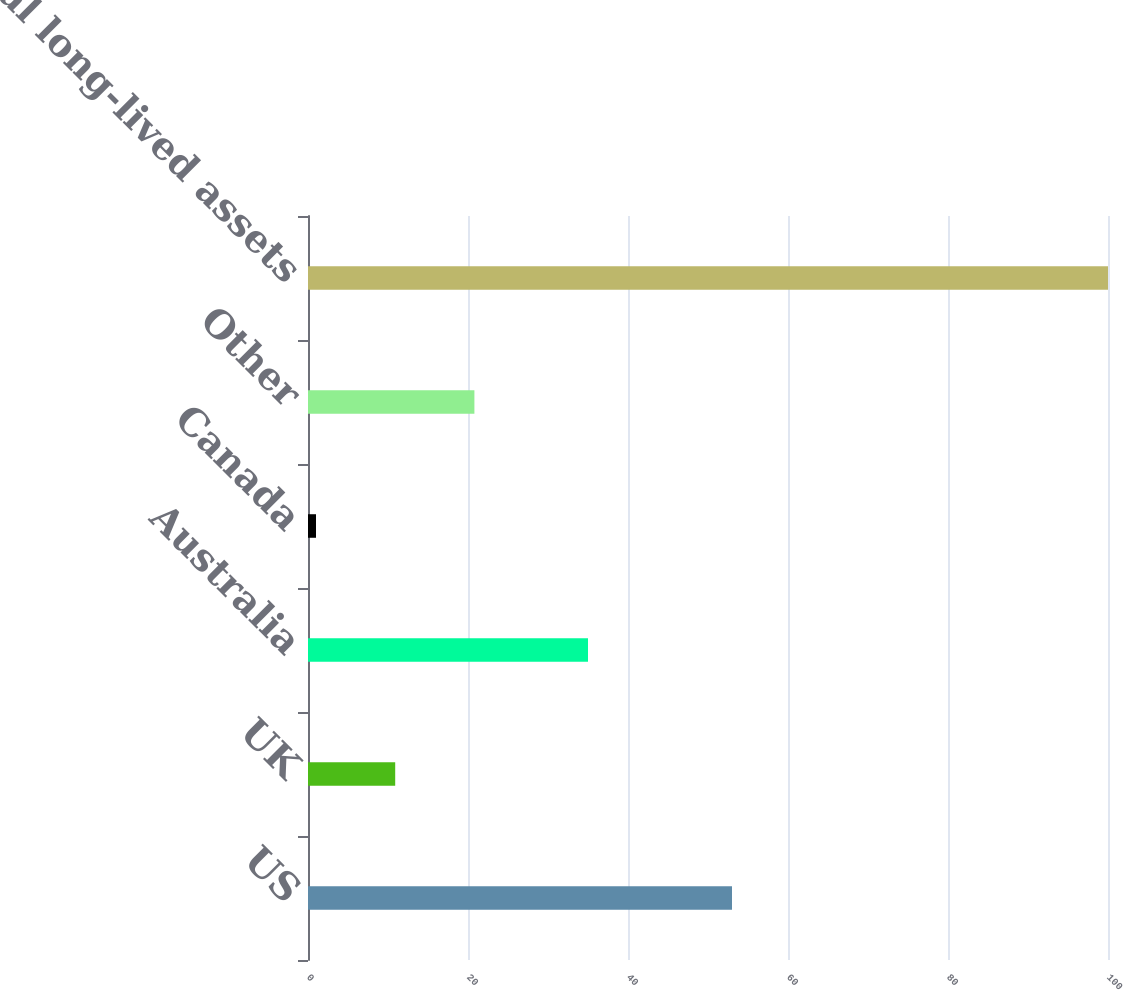<chart> <loc_0><loc_0><loc_500><loc_500><bar_chart><fcel>US<fcel>UK<fcel>Australia<fcel>Canada<fcel>Other<fcel>Total long-lived assets<nl><fcel>53<fcel>10.9<fcel>35<fcel>1<fcel>20.8<fcel>100<nl></chart> 